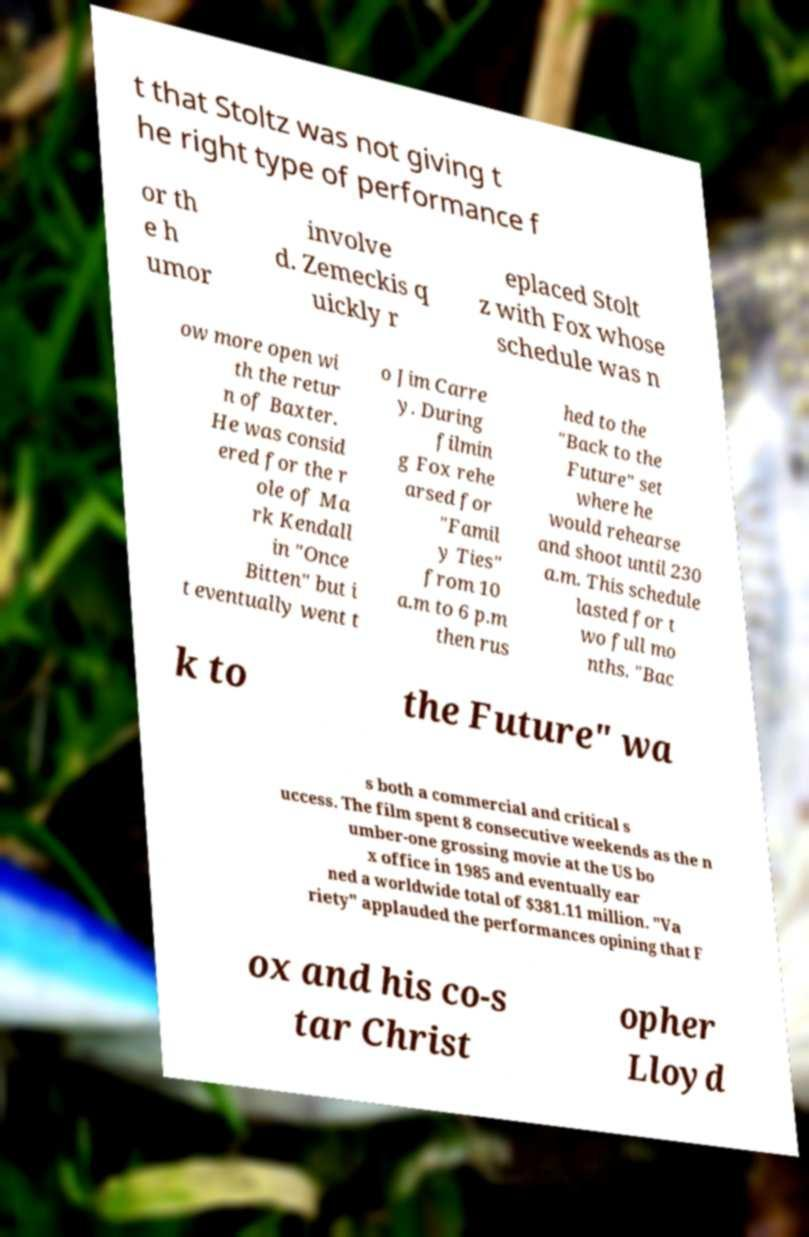For documentation purposes, I need the text within this image transcribed. Could you provide that? t that Stoltz was not giving t he right type of performance f or th e h umor involve d. Zemeckis q uickly r eplaced Stolt z with Fox whose schedule was n ow more open wi th the retur n of Baxter. He was consid ered for the r ole of Ma rk Kendall in "Once Bitten" but i t eventually went t o Jim Carre y. During filmin g Fox rehe arsed for "Famil y Ties" from 10 a.m to 6 p.m then rus hed to the "Back to the Future" set where he would rehearse and shoot until 230 a.m. This schedule lasted for t wo full mo nths. "Bac k to the Future" wa s both a commercial and critical s uccess. The film spent 8 consecutive weekends as the n umber-one grossing movie at the US bo x office in 1985 and eventually ear ned a worldwide total of $381.11 million. "Va riety" applauded the performances opining that F ox and his co-s tar Christ opher Lloyd 